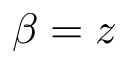<formula> <loc_0><loc_0><loc_500><loc_500>\beta = z</formula> 